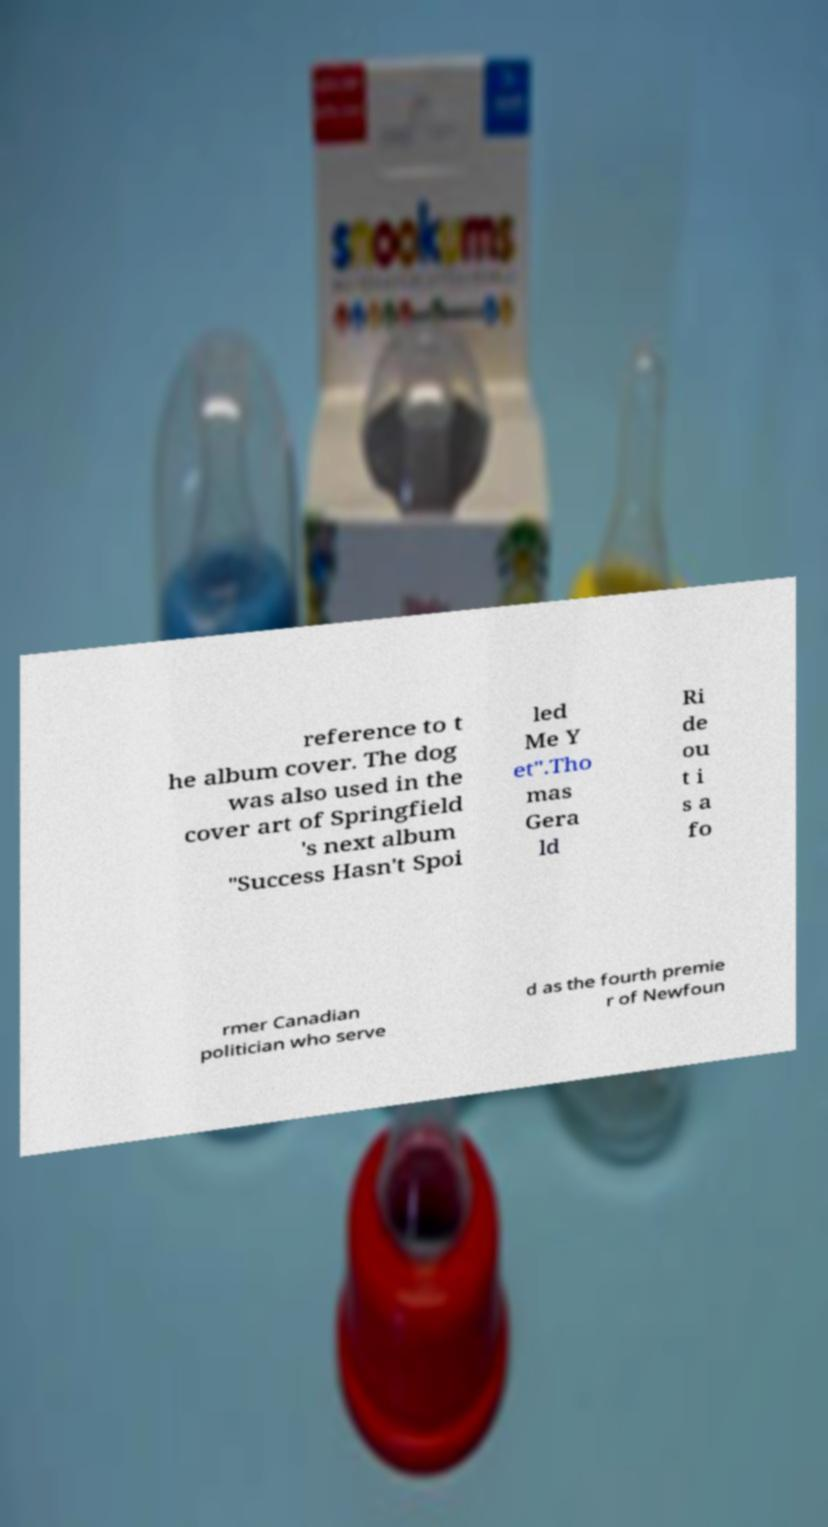Could you assist in decoding the text presented in this image and type it out clearly? reference to t he album cover. The dog was also used in the cover art of Springfield 's next album "Success Hasn't Spoi led Me Y et".Tho mas Gera ld Ri de ou t i s a fo rmer Canadian politician who serve d as the fourth premie r of Newfoun 